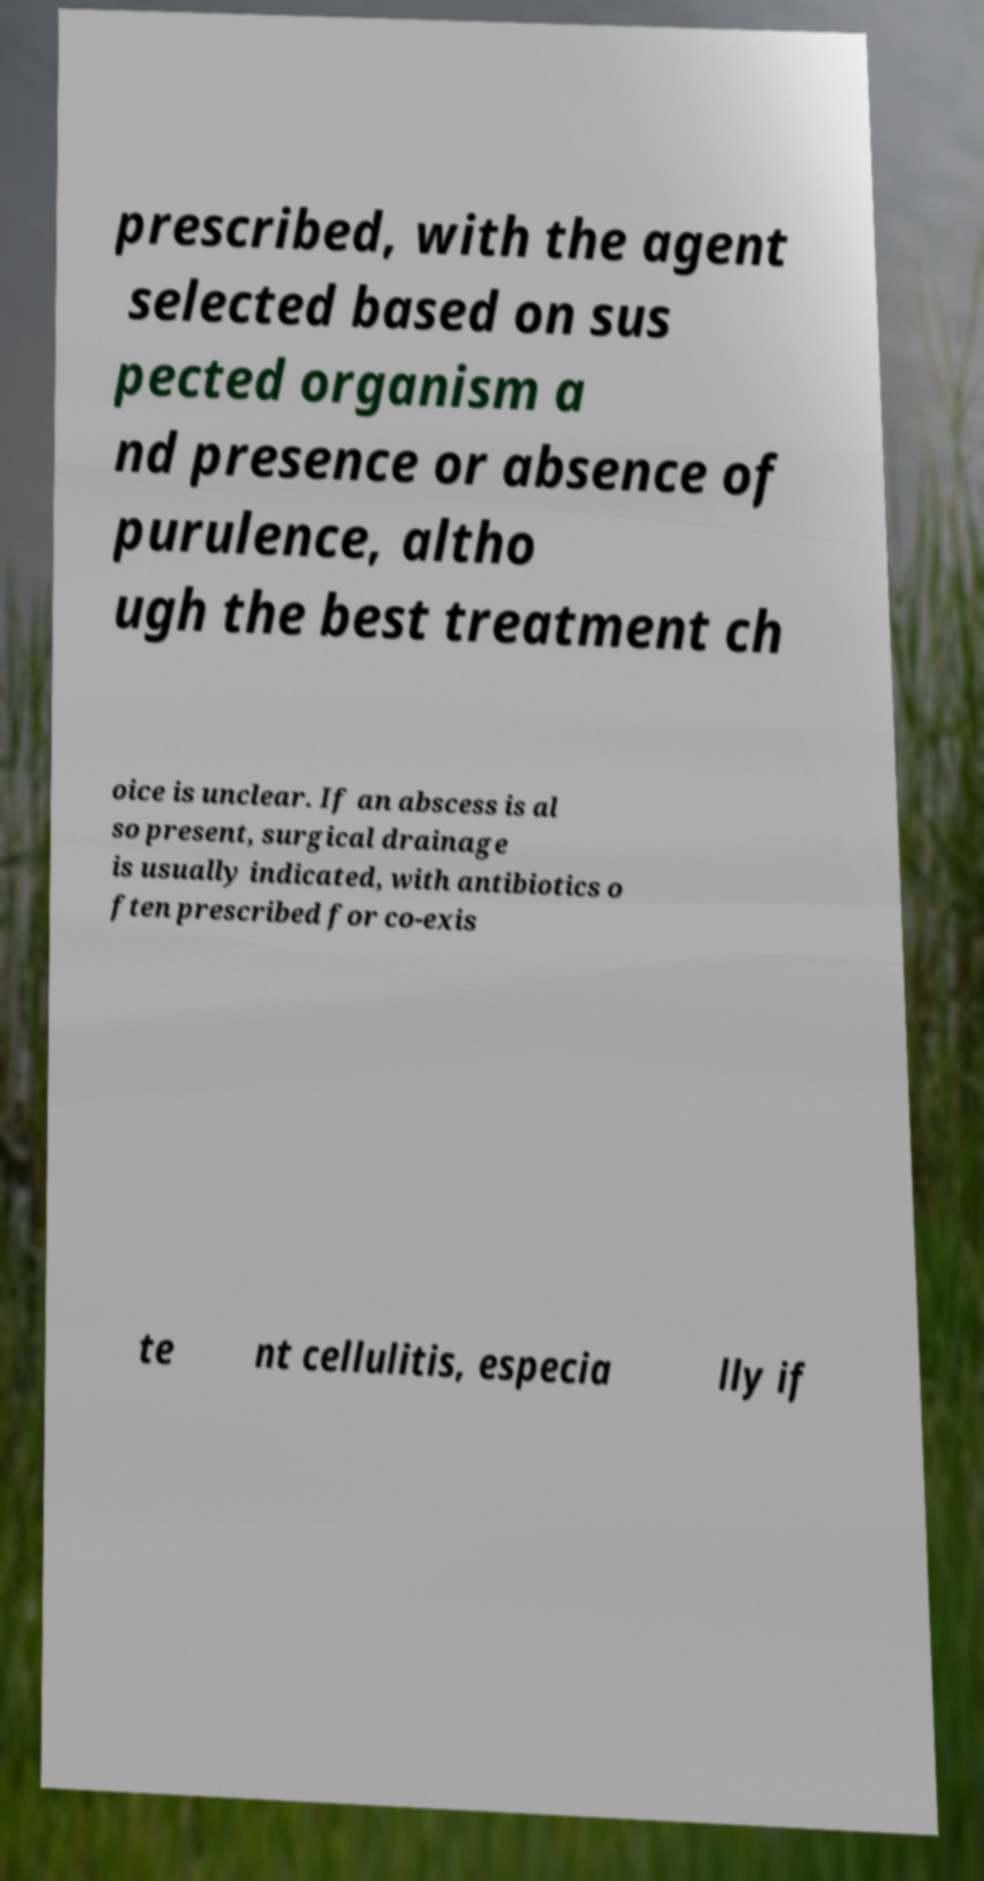For documentation purposes, I need the text within this image transcribed. Could you provide that? prescribed, with the agent selected based on sus pected organism a nd presence or absence of purulence, altho ugh the best treatment ch oice is unclear. If an abscess is al so present, surgical drainage is usually indicated, with antibiotics o ften prescribed for co-exis te nt cellulitis, especia lly if 